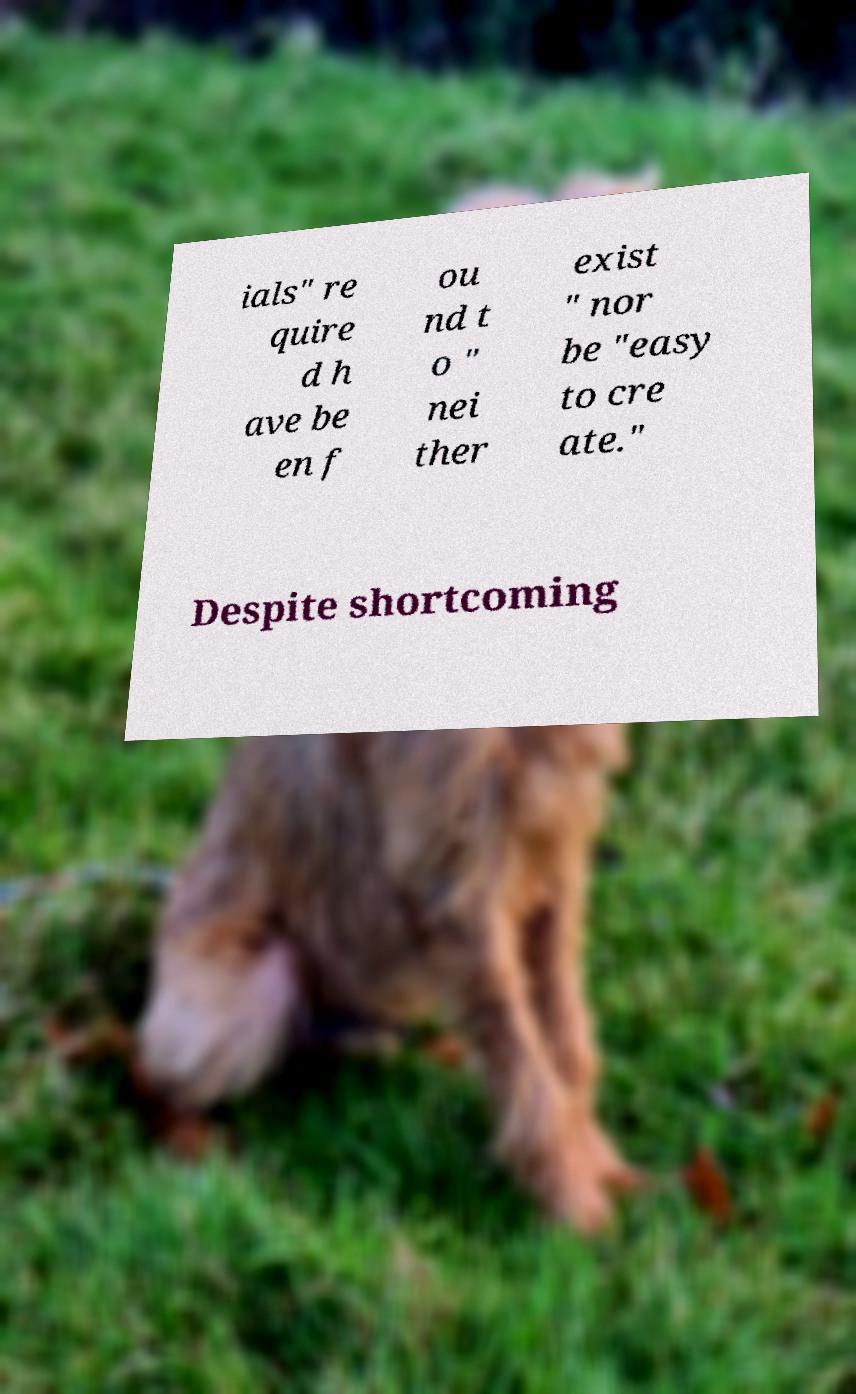For documentation purposes, I need the text within this image transcribed. Could you provide that? ials" re quire d h ave be en f ou nd t o " nei ther exist " nor be "easy to cre ate." Despite shortcoming 